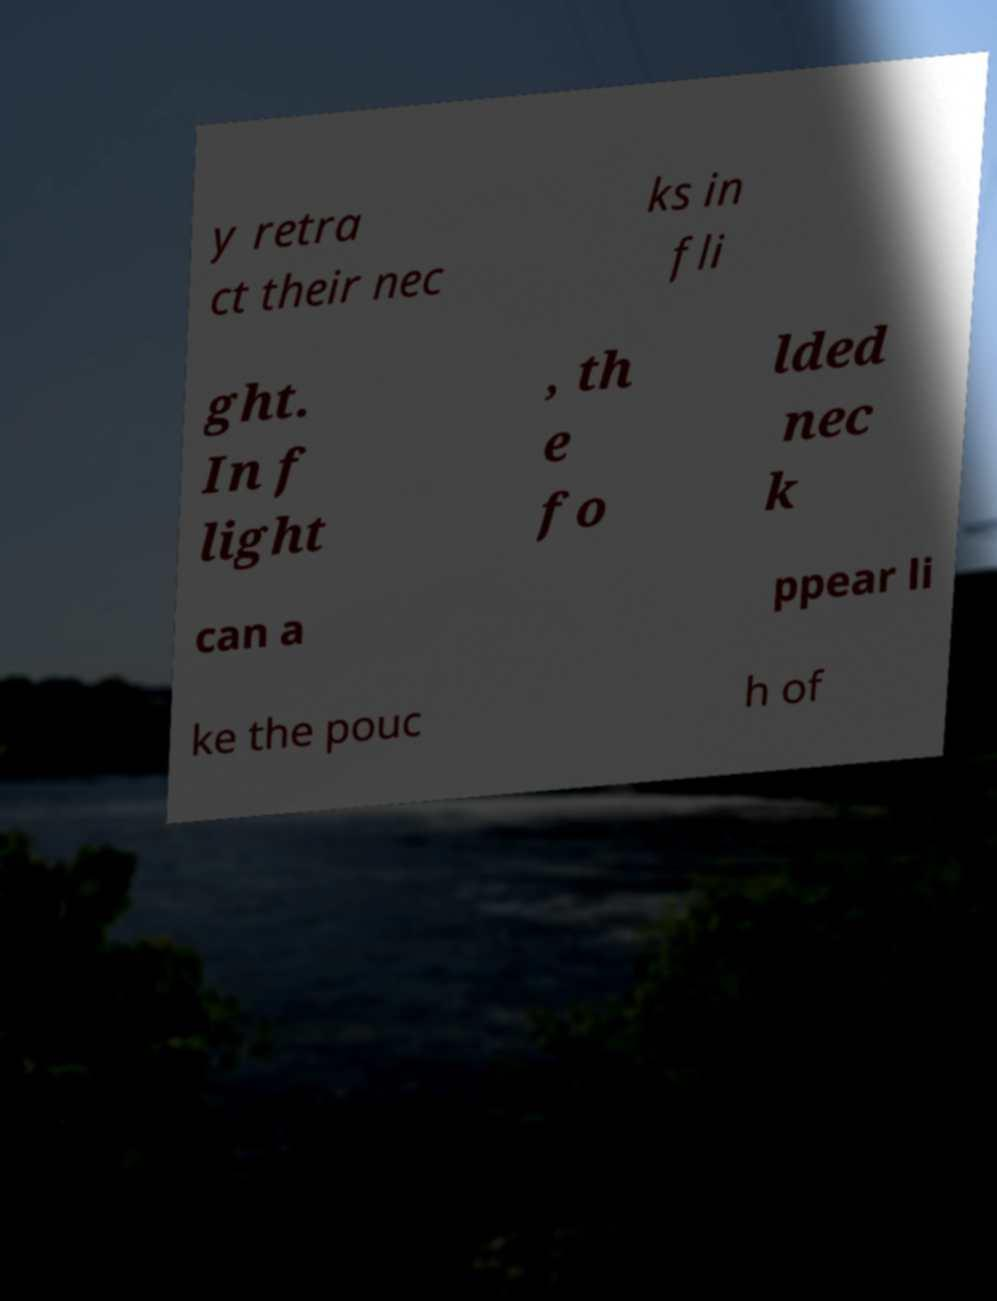Could you extract and type out the text from this image? y retra ct their nec ks in fli ght. In f light , th e fo lded nec k can a ppear li ke the pouc h of 